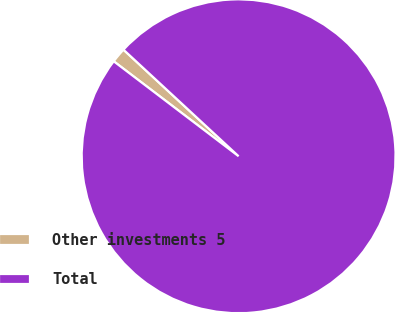<chart> <loc_0><loc_0><loc_500><loc_500><pie_chart><fcel>Other investments 5<fcel>Total<nl><fcel>1.54%<fcel>98.46%<nl></chart> 